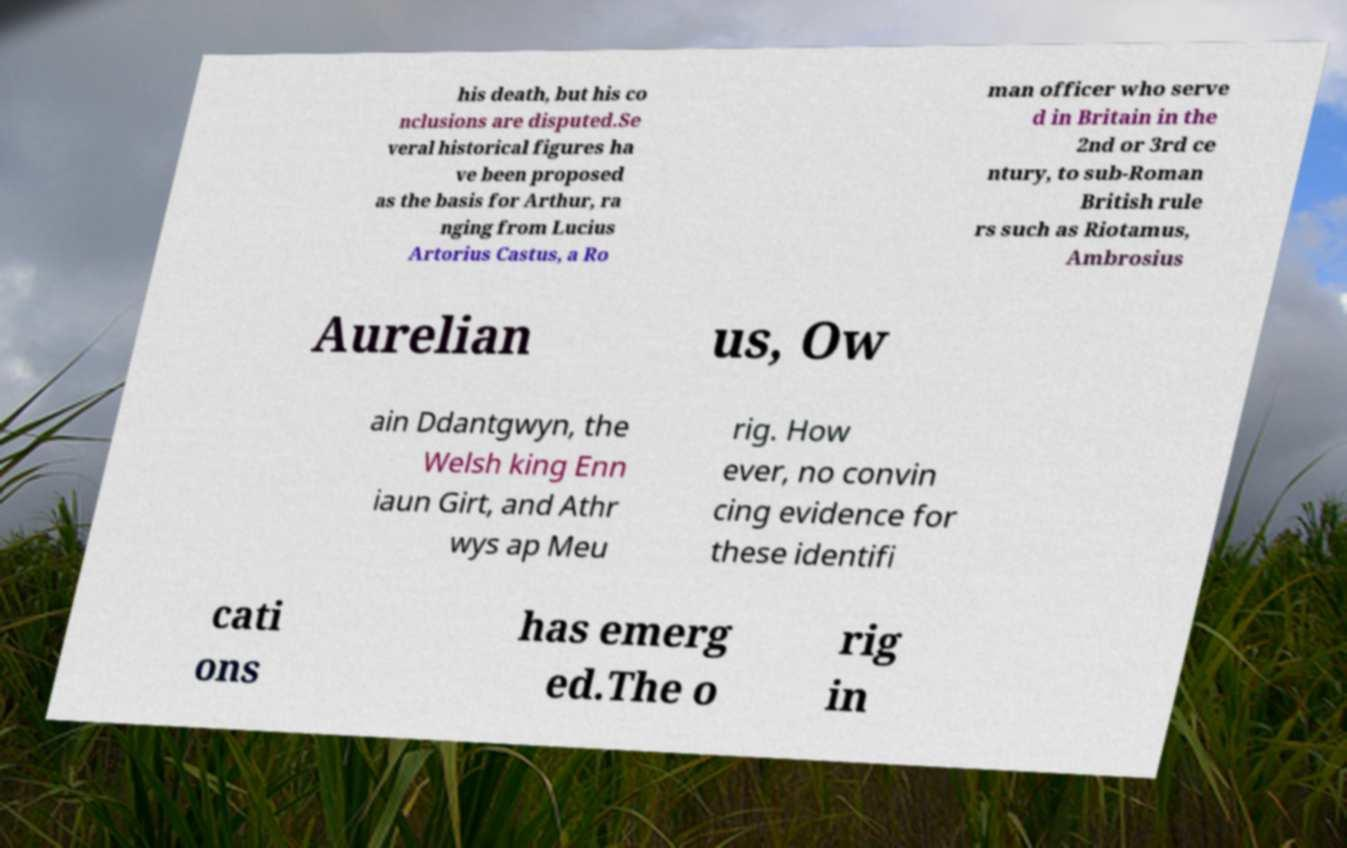Please read and relay the text visible in this image. What does it say? his death, but his co nclusions are disputed.Se veral historical figures ha ve been proposed as the basis for Arthur, ra nging from Lucius Artorius Castus, a Ro man officer who serve d in Britain in the 2nd or 3rd ce ntury, to sub-Roman British rule rs such as Riotamus, Ambrosius Aurelian us, Ow ain Ddantgwyn, the Welsh king Enn iaun Girt, and Athr wys ap Meu rig. How ever, no convin cing evidence for these identifi cati ons has emerg ed.The o rig in 